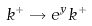Convert formula to latex. <formula><loc_0><loc_0><loc_500><loc_500>k ^ { + } \rightarrow e ^ { y } k ^ { + }</formula> 